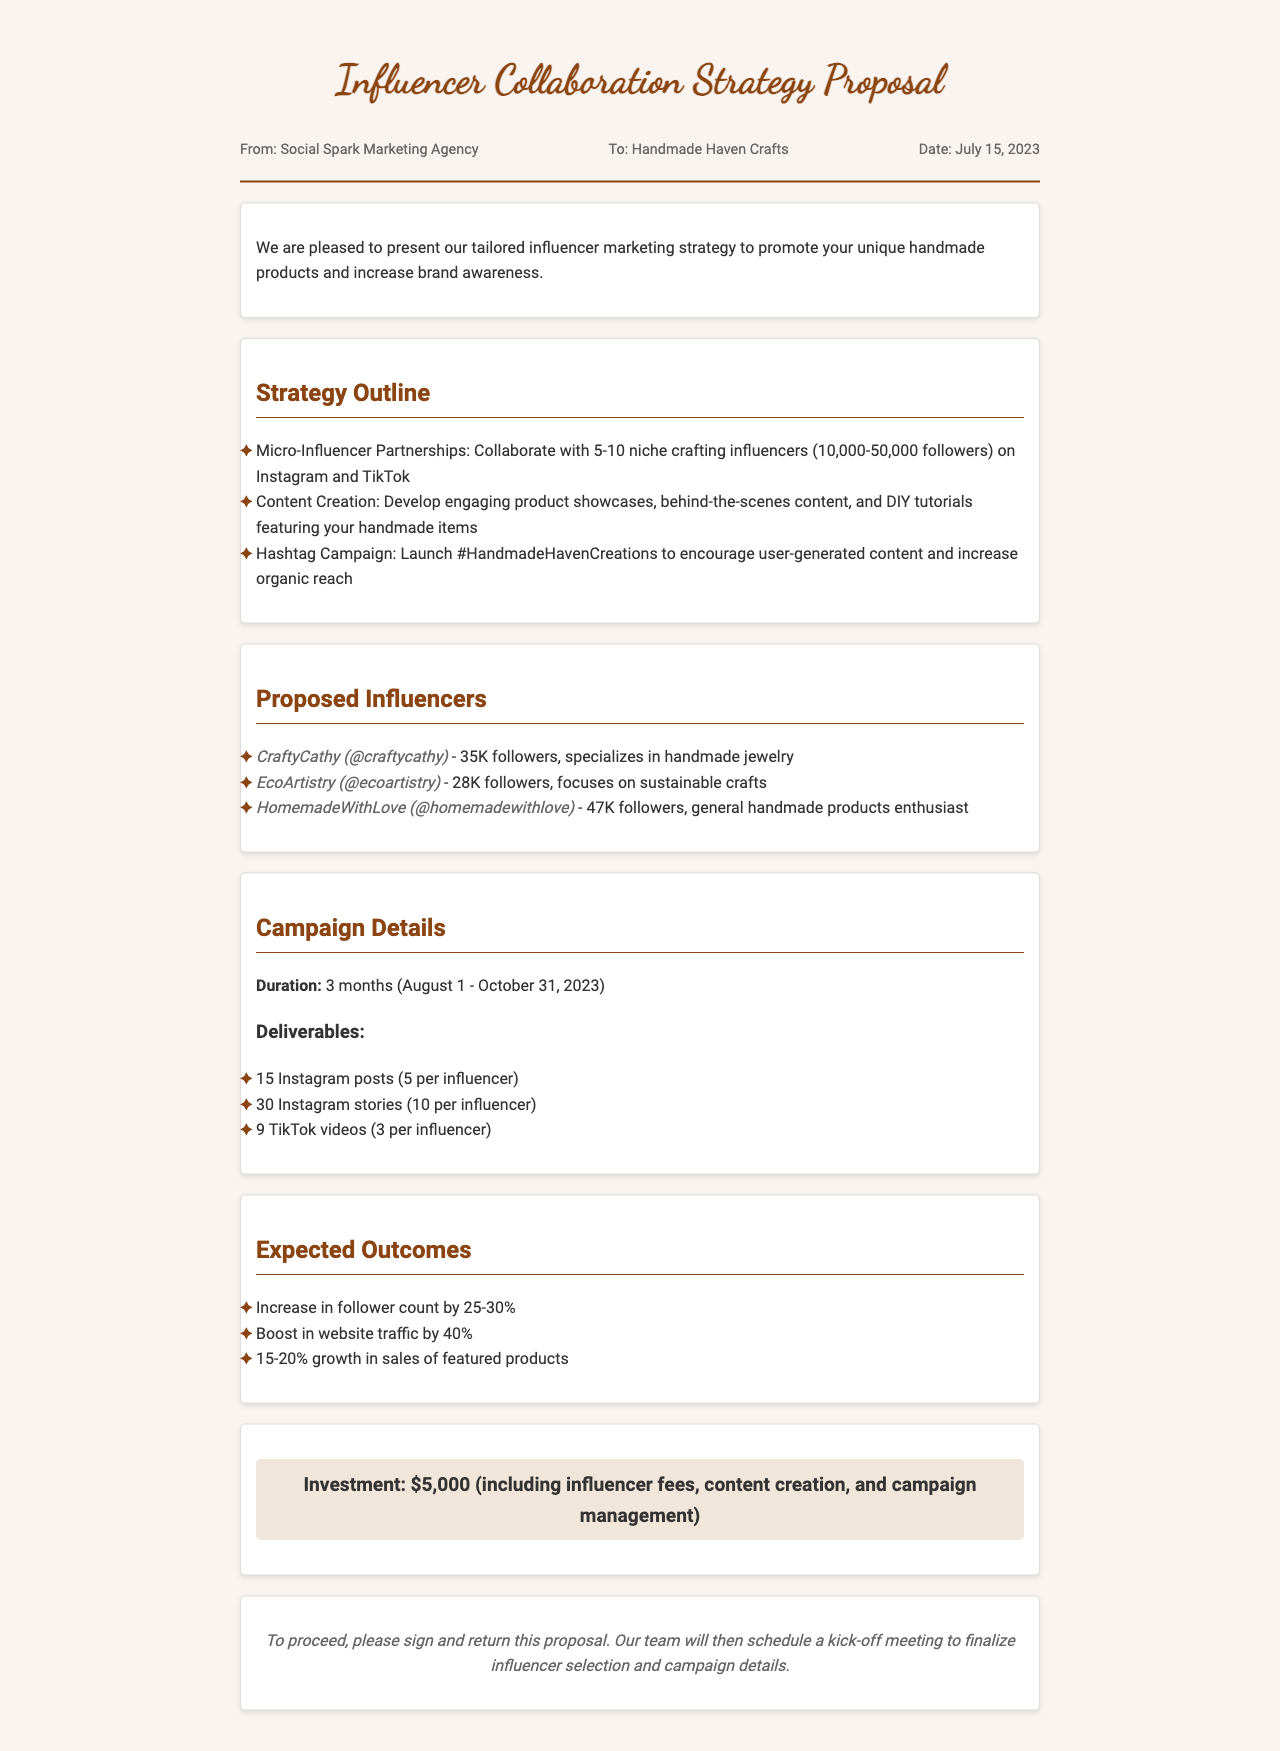What is the name of the marketing agency? The marketing agency that sent the proposal is identified as Social Spark Marketing Agency.
Answer: Social Spark Marketing Agency What is the proposal date? The date mentioned in the proposal is July 15, 2023.
Answer: July 15, 2023 How many influencers are planned for the campaign? The proposal indicates a collaboration with 5-10 niche crafting influencers.
Answer: 5-10 What is the campaign duration? The proposal states that the campaign will run for three months from August 1 to October 31, 2023.
Answer: 3 months What is the expected increase in follower count? The proposal anticipates an increase in follower count by 25-30%.
Answer: 25-30% What is the total investment for the campaign? The total investment outlined in the proposal is comprised of influencer fees, content creation, and campaign management totaling $5,000.
Answer: $5,000 Which influencer specializes in handmade jewelry? The influencer noted for specializing in handmade jewelry is CraftyCathy.
Answer: CraftyCathy What hashtag is proposed for user-generated content? The proposed hashtag to encourage user-generated content is #HandmadeHavenCreations.
Answer: #HandmadeHavenCreations What is the goal for website traffic increase? The document mentions a goal to boost website traffic by 40%.
Answer: 40% 